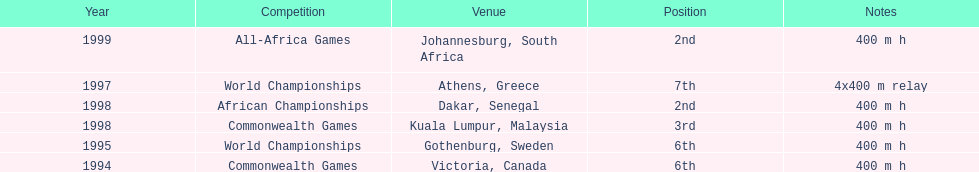What is the number of titles ken harden has one 6. 